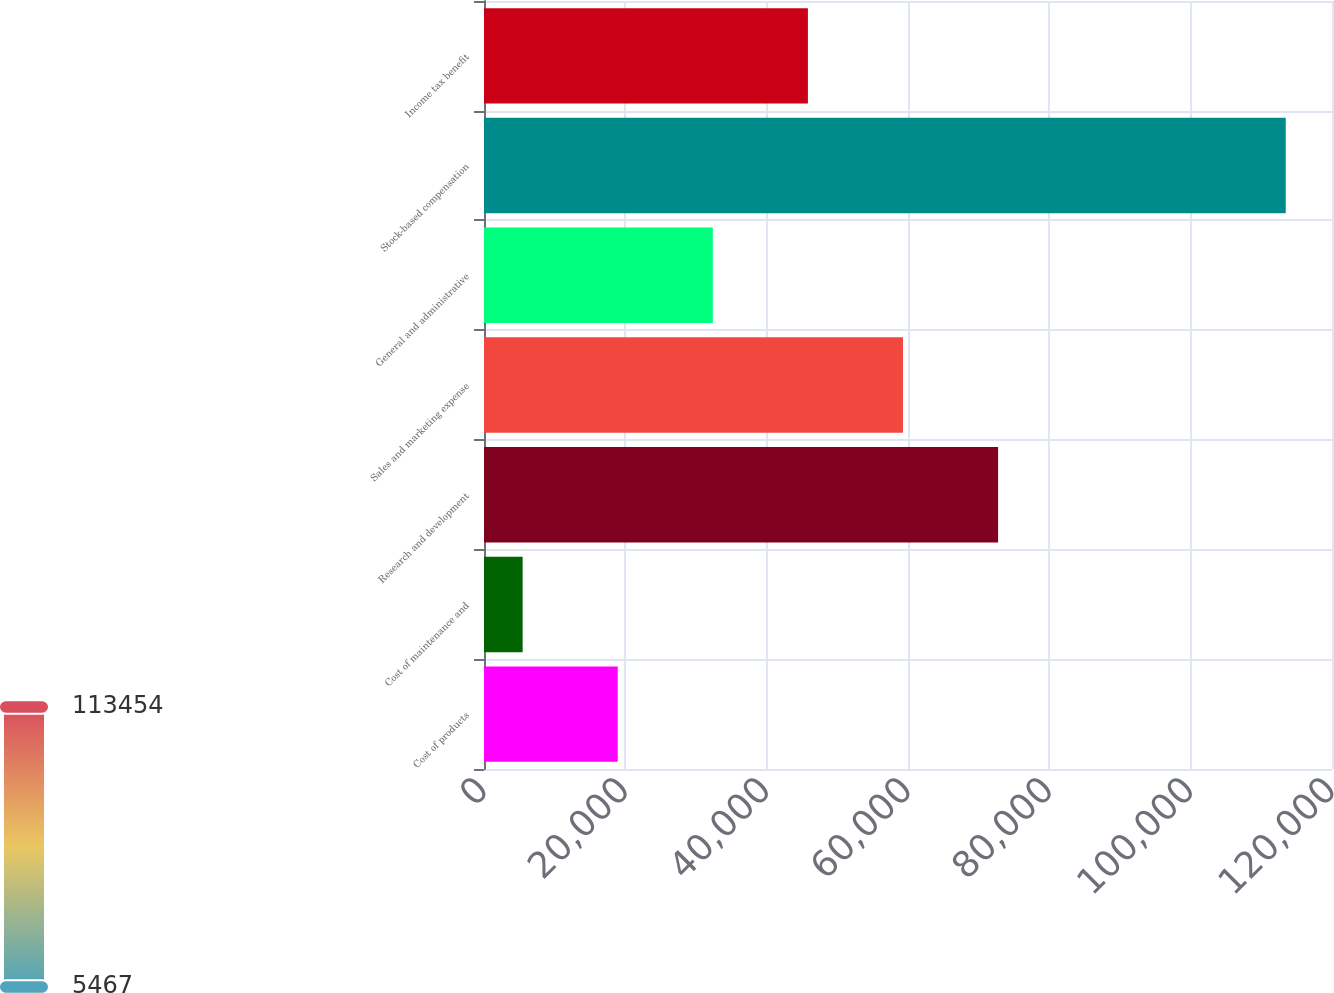Convert chart to OTSL. <chart><loc_0><loc_0><loc_500><loc_500><bar_chart><fcel>Cost of products<fcel>Cost of maintenance and<fcel>Research and development<fcel>Sales and marketing expense<fcel>General and administrative<fcel>Stock-based compensation<fcel>Income tax benefit<nl><fcel>18923.5<fcel>5467<fcel>72749.5<fcel>59293<fcel>32380<fcel>113454<fcel>45836.5<nl></chart> 